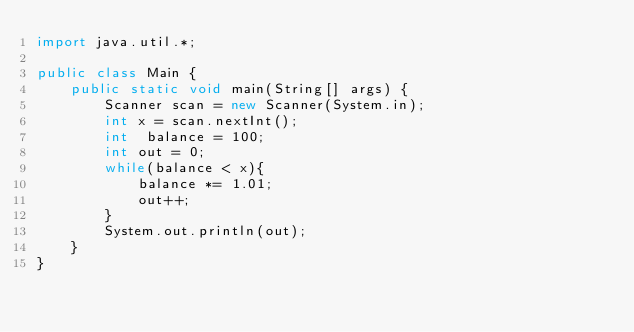<code> <loc_0><loc_0><loc_500><loc_500><_Java_>import java.util.*;

public class Main {
    public static void main(String[] args) {
        Scanner scan = new Scanner(System.in);
        int x = scan.nextInt();
        int  balance = 100;
        int out = 0;
        while(balance < x){
            balance *= 1.01;
            out++;
        }
        System.out.println(out);
    }
}</code> 